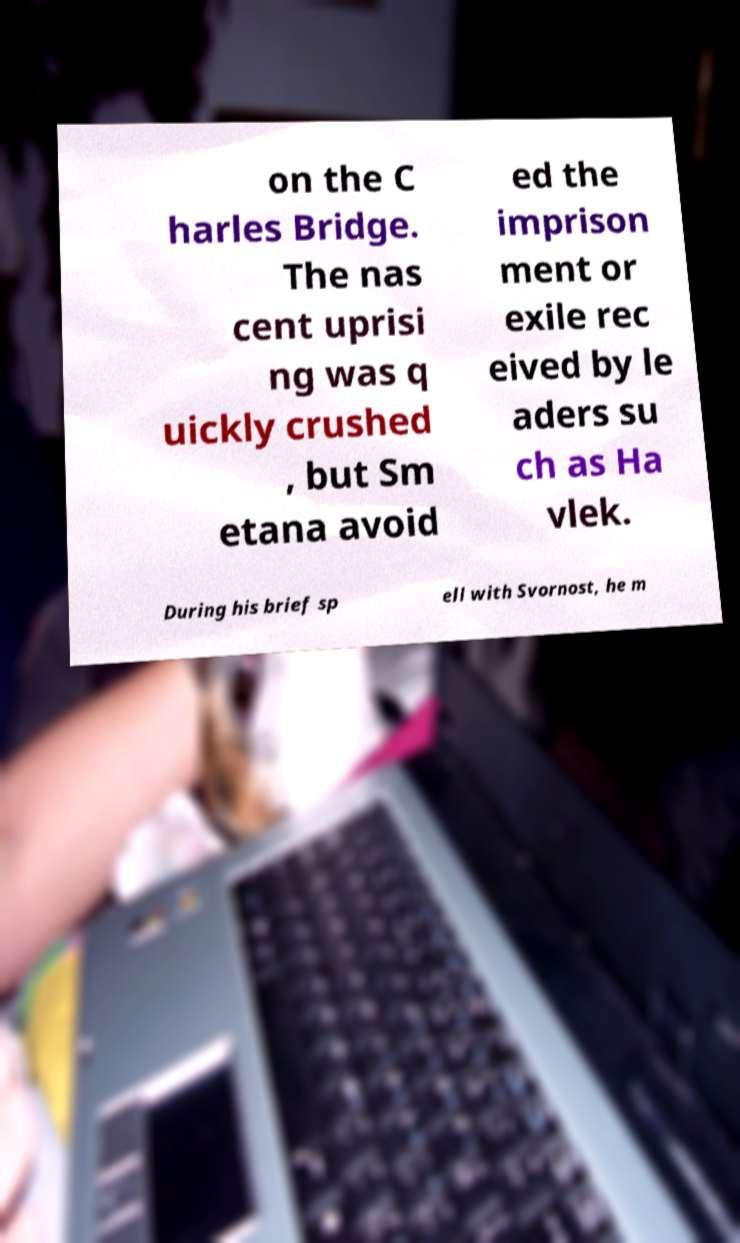What messages or text are displayed in this image? I need them in a readable, typed format. on the C harles Bridge. The nas cent uprisi ng was q uickly crushed , but Sm etana avoid ed the imprison ment or exile rec eived by le aders su ch as Ha vlek. During his brief sp ell with Svornost, he m 